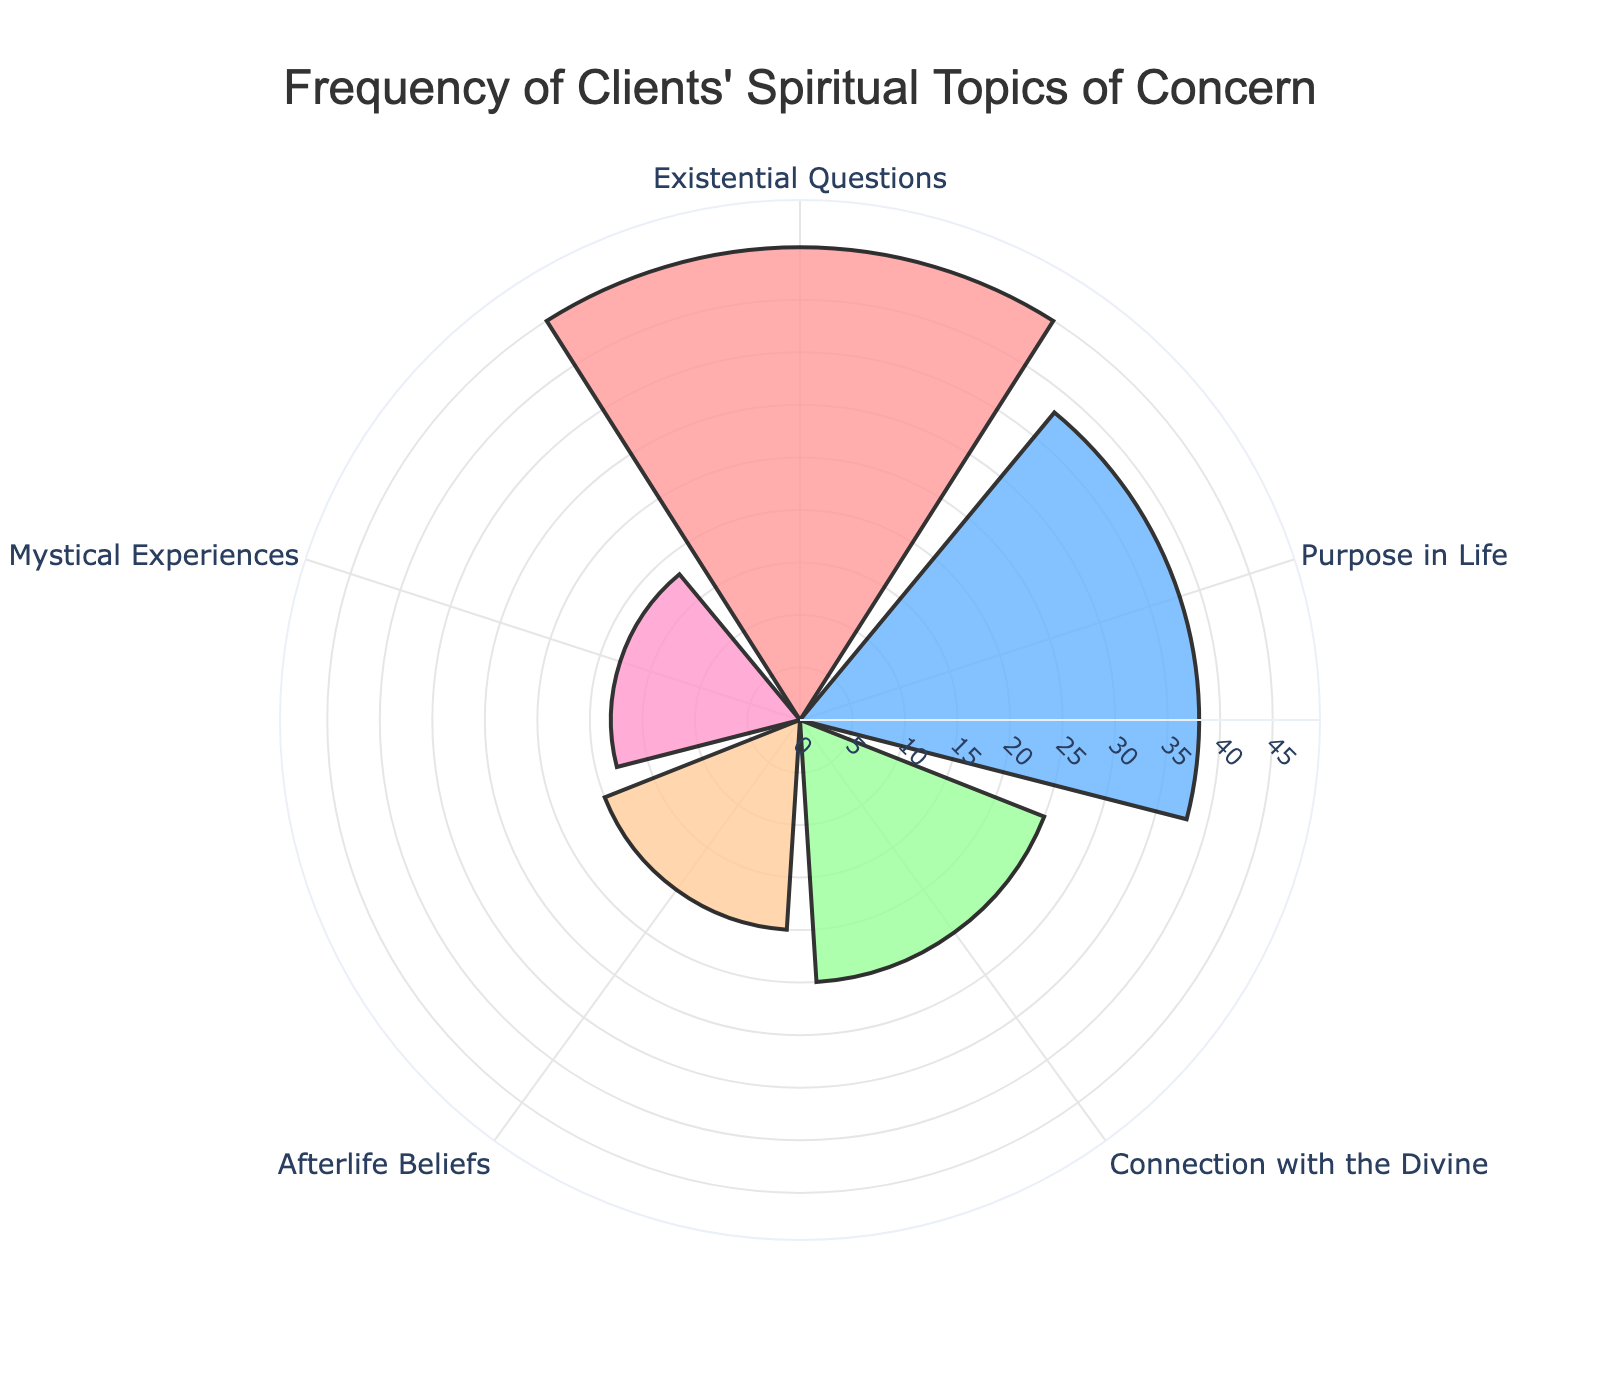What's the title of the chart? The title of the chart is displayed at the top center of the figure. It reads "Frequency of Clients' Spiritual Topics of Concern".
Answer: Frequency of Clients' Spiritual Topics of Concern How many categories of spiritual topics are represented in the chart? The chart has categories labeled at different angles. Counting these labels gives five categories.
Answer: Five Which spiritual topic is the most frequent concern among clients? The length of the bars in the chart indicates the frequency. The longest bar corresponds to the category "Existential Questions".
Answer: Existential Questions What is the total frequency count for all spiritual topics combined? Adding up the counts from all categories: 45 + 38 + 25 + 20 + 18 equals 146.
Answer: 146 Compare the frequency of "Existential Questions" to "Mystical Experiences". Which is higher and by how much? "Existential Questions" has a count of 45, and "Mystical Experiences" has a count of 18. Subtracting these, 45 - 18 equals 27.
Answer: Existential Questions by 27 Which spiritual topic has the third highest frequency concern? By inspecting the length of the bars from highest to lowest, the third longest bar corresponds to "Connection with the Divine".
Answer: Connection with the Divine What is the average frequency of the given spiritual topics? Summing the counts: 45 + 38 + 25 + 20 + 18 gives 146. Dividing by the number of categories, 146 / 5 equals 29.2.
Answer: 29.2 Is the frequency of "Purpose in Life" more than double that of "Mystical Experiences"? The count for "Purpose in Life" is 38, and the count for "Mystical Experiences" is 18. Checking if 38 is more than twice 18: 18 x 2 equals 36, and 38 is indeed greater than 36.
Answer: Yes Which two topics have a combined frequency closest to the total frequency of "Existential Questions"? The frequency counts of "Purpose in Life" (38) and "Afterlife Beliefs" (20) add up to 38 + 20 = 58, which is closest to 45.
Answer: Purpose in Life and Afterlife Beliefs 